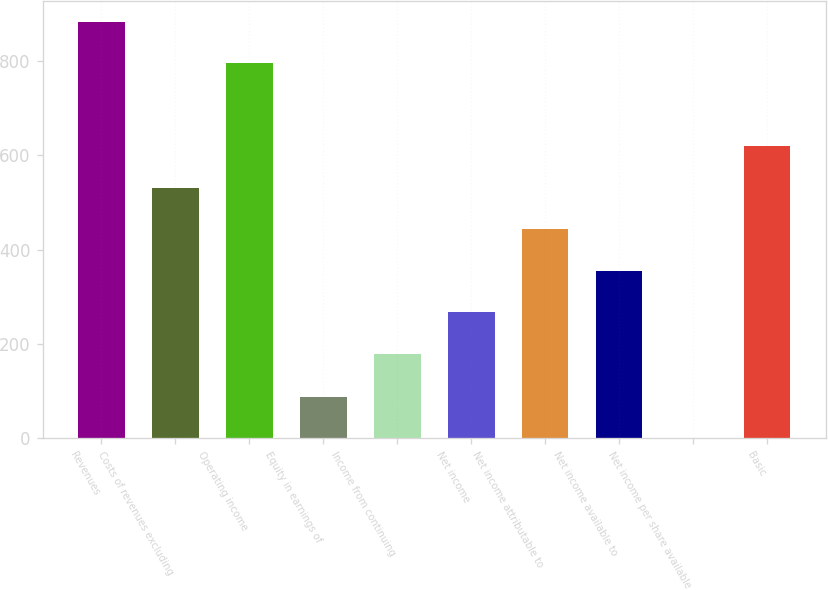<chart> <loc_0><loc_0><loc_500><loc_500><bar_chart><fcel>Revenues<fcel>Costs of revenues excluding<fcel>Operating income<fcel>Equity in earnings of<fcel>Income from continuing<fcel>Net income<fcel>Net income attributable to<fcel>Net income available to<fcel>Net income per share available<fcel>Basic<nl><fcel>883.48<fcel>531.24<fcel>795.42<fcel>88.49<fcel>179<fcel>267.06<fcel>443.18<fcel>355.12<fcel>0.43<fcel>619.3<nl></chart> 